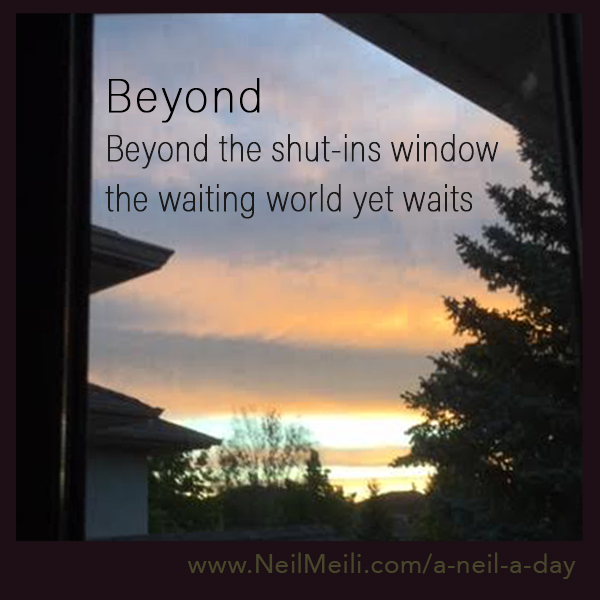What time of day does the image suggest, and what are the indicators that lead to this conclusion? The image suggests it is either sunrise or sunset, indicated by the warm hues of yellow, orange, and pink near the horizon. These colors typically appear when the sun is low in the sky. Additional context such as the direction the window is facing or the specific time the photo was taken would provide more clarity. The poetic nature of the text in the image complements the serene ambiance often associated with these times of day. 